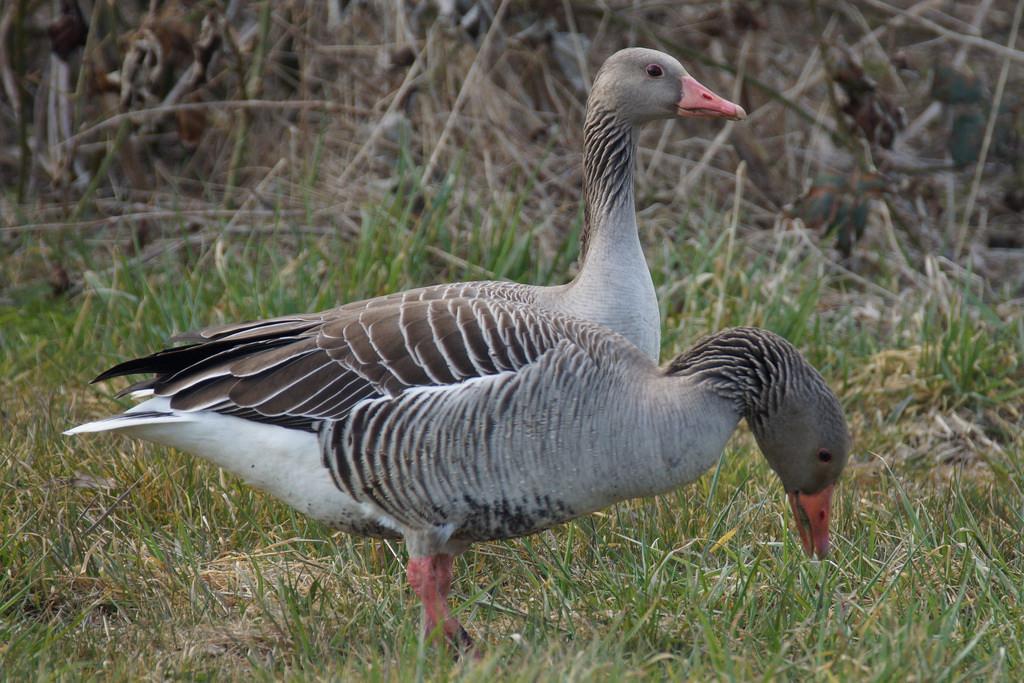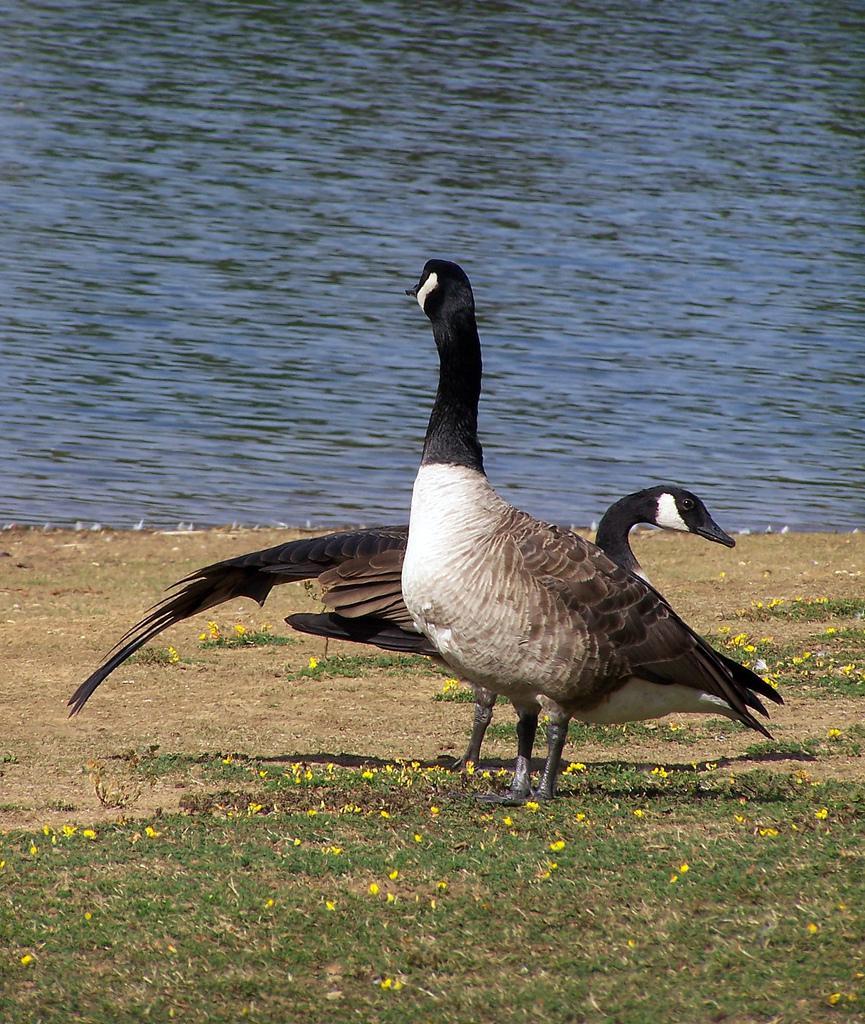The first image is the image on the left, the second image is the image on the right. For the images displayed, is the sentence "The left image shows two geese standing with bodies overlapping and upright heads close together and facing left." factually correct? Answer yes or no. No. 